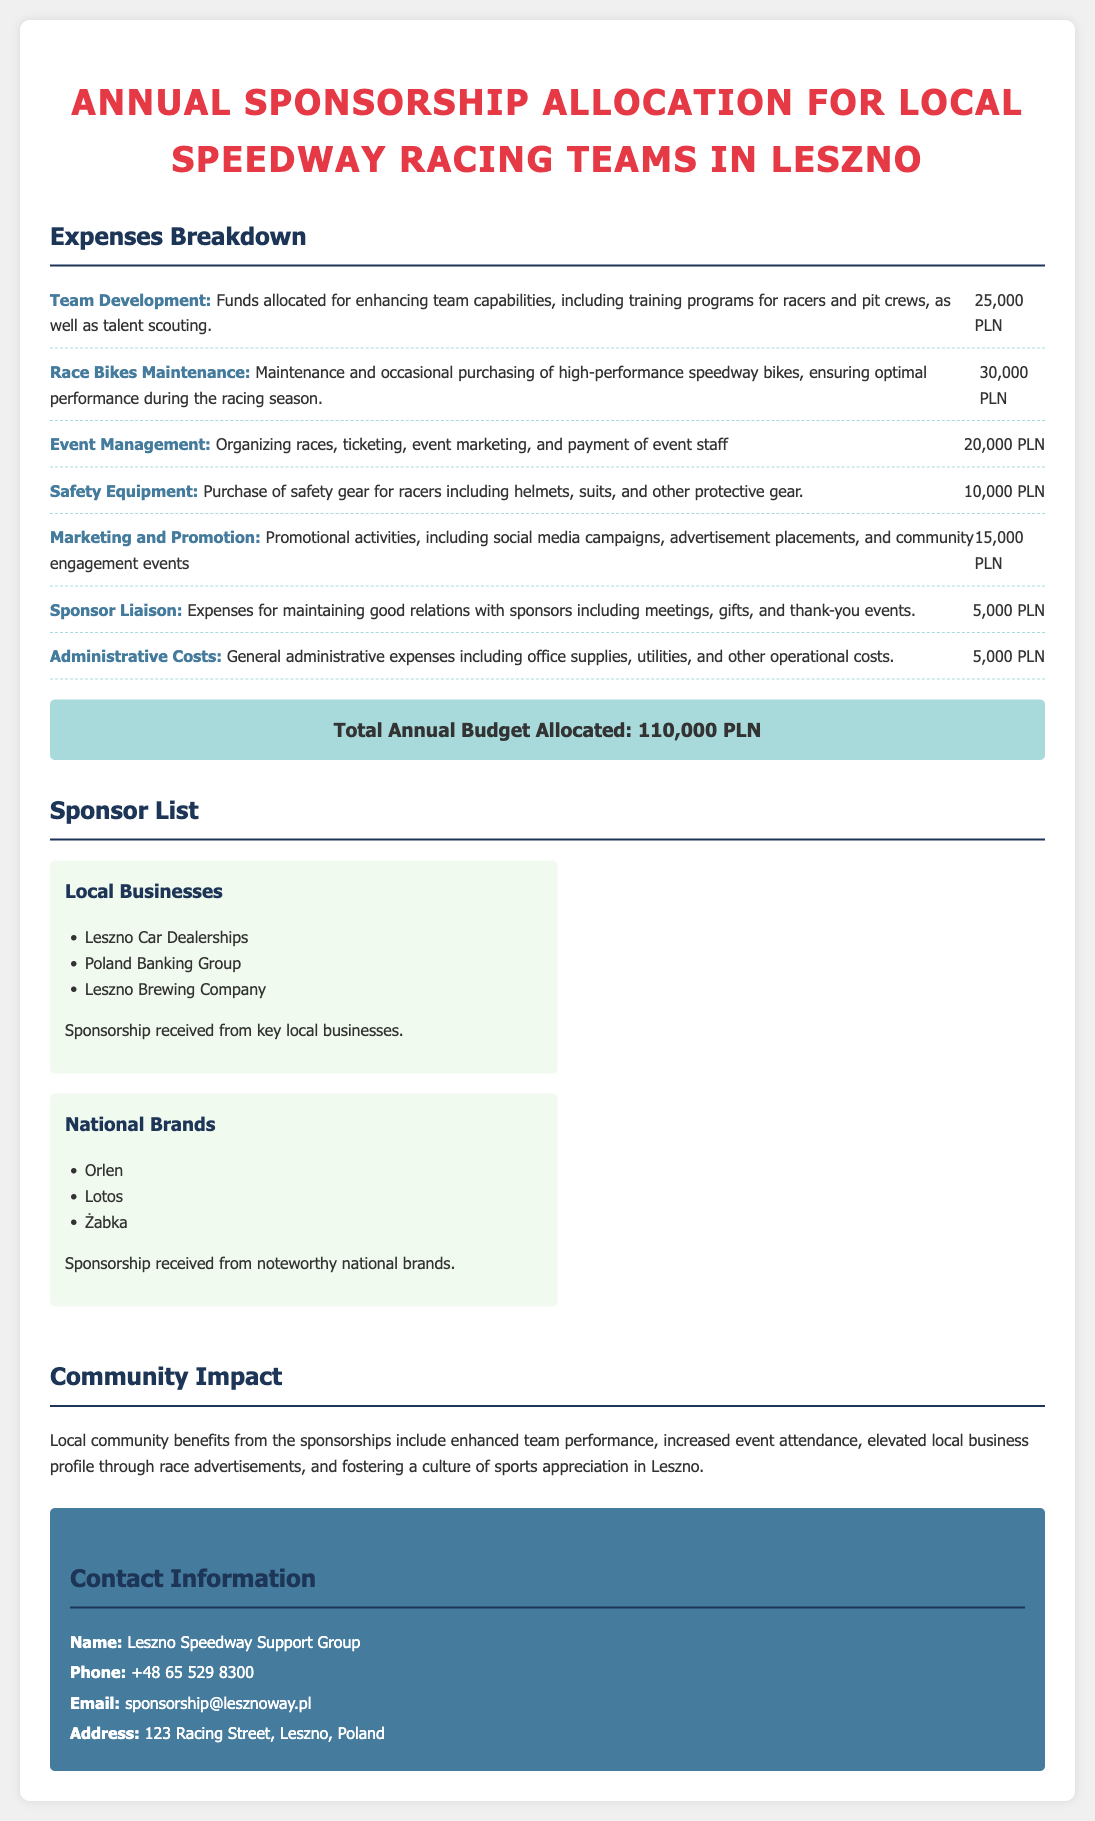what is the total annual budget allocated? The total annual budget allocated is prominently stated in the document under the total budget section.
Answer: 110,000 PLN how much is allocated for race bikes maintenance? The amount allocated for race bikes maintenance is listed explicitly in the expenses breakdown.
Answer: 30,000 PLN who received sponsorship from local businesses? The document lists specific businesses under the local businesses category for sponsorship.
Answer: Leszno Car Dealerships, Poland Banking Group, Leszno Brewing Company what is the purpose of the safety equipment budget? The purpose of the safety equipment budget is mentioned in detail in the expenses breakdown.
Answer: Purchase of safety gear for racers how many PLN is allocated for marketing and promotion? The allocation for marketing and promotion is found in the expenses breakdown section.
Answer: 15,000 PLN what is the primary contact organization named? The name of the primary contact organization is stated in the contact information section.
Answer: Leszno Speedway Support Group what type of businesses are listed under national brands? The document provides specific examples of companies under the national brands category in the sponsor list.
Answer: Orlen, Lotos, Żabka how much is allocated for team development? The specific amount allocated for team development is included in the budget breakdown.
Answer: 25,000 PLN 